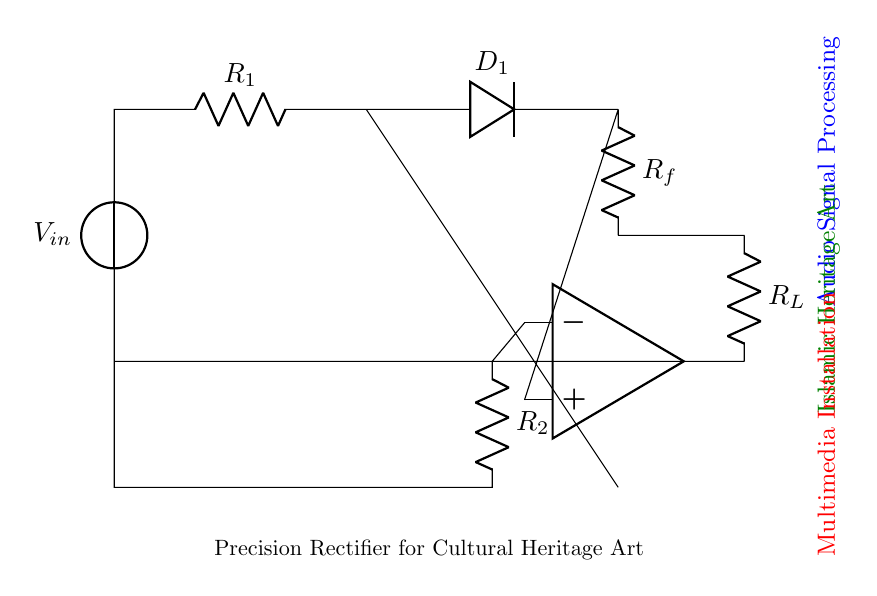What is the main function of this circuit? The circuit is designed to rectify an audio signal, converting it from alternating current to direct current. This function is achieved through the use of diodes and operational amplifiers, which process the input signal and control the flow of current.
Answer: Rectification How many resistors are in the circuit? There are three resistors present: R1, R2, and Rf. Each serves a unique function in controlling current and voltage within the circuit. Identifying the resistors involves counting the symbols labeled as 'R' in the circuit diagram.
Answer: Three What is the purpose of the operational amplifier in this circuit? The operational amplifier is utilized to amplify and process the audio signal accurately while providing high input impedance and low output impedance. It allows for better control of the signal, ensuring that the rectification is precise and efficient.
Answer: Amplification What type of rectifier is represented in this circuit? This circuit is a precision rectifier, which is specifically designed to handle weak signals such as audio inputs, providing accurate rectification even at low levels. Unlike standard rectifiers, it utilizes an operational amplifier, which enhances its performance for precise applications.
Answer: Precision rectifier What does the diode do in this circuit? The diode (D1) allows current to flow only in one direction, blocking reverse current flow. This function is critical in the rectifying process, directing the audio signal to pass through while preventing any negative voltage from influencing the output.
Answer: Allow current one way What is the role of the load resistor R_L in this circuit? The load resistor R_L serves as a component that connects to the output of the circuit, allowing the processed signal to be used or measured. It helps define the circuit's overall behavior and ensures that the output signal is suitable for further stages of audio processing or utilization in an art installation.
Answer: Connects output What is the relationship between R_f and the precision of this rectifier? The feedback resistor R_f plays a crucial role in determining the gain of the operational amplifier, affecting the precision of the rectifier. A properly chosen R_f value optimizes the circuit's performance, ensuring minimal distortion and improved accuracy during the rectification of audio signals.
Answer: Feedback control precision 